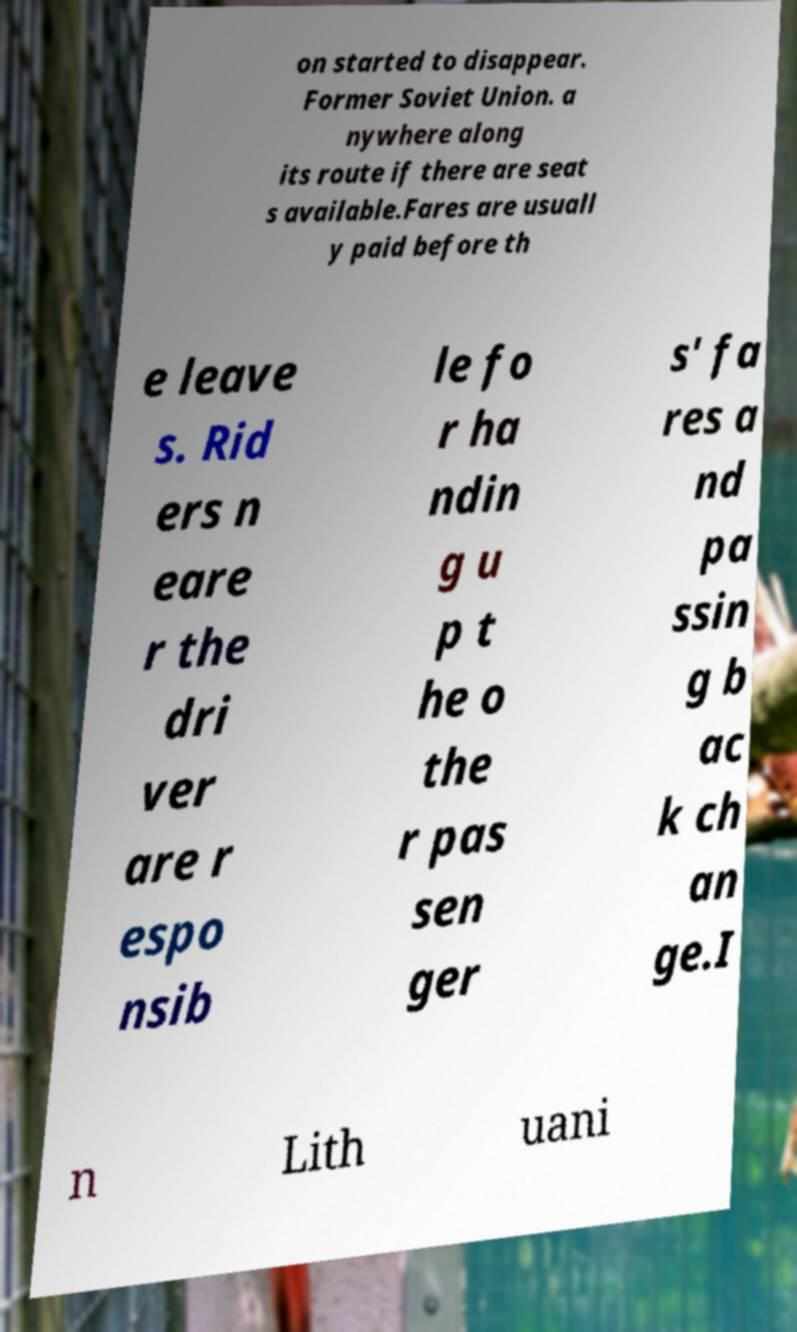Could you extract and type out the text from this image? on started to disappear. Former Soviet Union. a nywhere along its route if there are seat s available.Fares are usuall y paid before th e leave s. Rid ers n eare r the dri ver are r espo nsib le fo r ha ndin g u p t he o the r pas sen ger s' fa res a nd pa ssin g b ac k ch an ge.I n Lith uani 